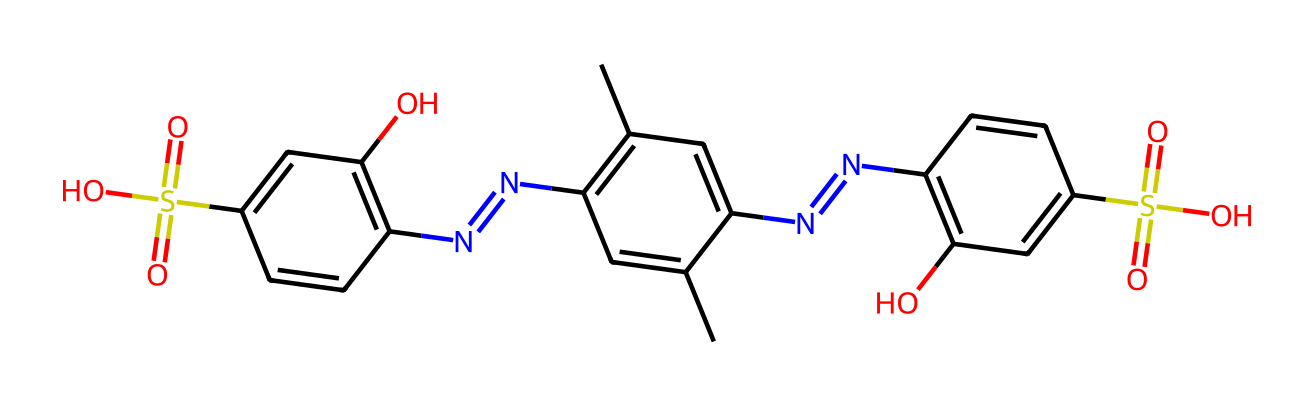How many nitrogen atoms are in the structure? To find the number of nitrogen atoms, I need to look for occurrences of the nitrogen symbol (N) in the SMILES representation. I see three instances, indicating there are three nitrogen atoms present in the structure.
Answer: three What functional groups are present in this dye? A closer inspection reveals sulfonic acid groups (indicated by S(=O)(=O)O) and hydroxyl groups (indicated by O), which are typical functional groups found in dyes that contribute to their solubility and color properties.
Answer: sulfonic acid and hydroxyl What type of chemical compound is this dye mainly classified as? Given the presence of multiple conjugated systems and the intention of bright coloration characteristic of this structure, this dye is classified primarily as an azo dye due to the presence of repeated nitrogen linkages (N=N).
Answer: azo dye How many carbon atoms are in the molecule? To determine the carbon count, I search for carbon (C) occurrences in the SMILES representation. I count a total of 18 carbon atoms present in the structure.
Answer: eighteen What is the application of this fluorescent dye in soccer balls? The application of this fluorescent dye in soccer balls is primarily for achieving high visibility, making the ball easier to see under different lighting conditions, especially at night or in low light.
Answer: visibility What would happen if this dye were not used? Without this fluorescent dye, the soccer ball would have reduced visibility, making it harder for players and spectators to track the ball during play, potentially affecting the game experience.
Answer: reduced visibility 